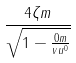<formula> <loc_0><loc_0><loc_500><loc_500>\frac { 4 \zeta m } { \sqrt { 1 - \frac { 0 m } { v u ^ { 0 } } } }</formula> 